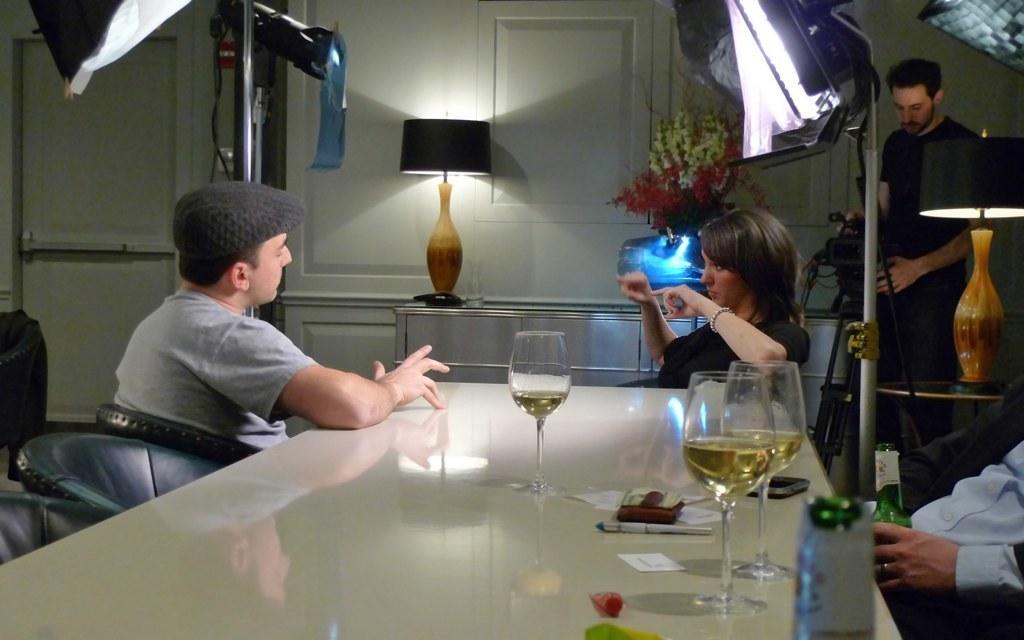Please provide a concise description of this image. in this back ground the three people they are sitting on chair and one person he is standing and he is holding the camera and in this room the table and the bed lamp and some flower vase are there and table has some wine glasses some mobile and purse is there and the back ground is white. 